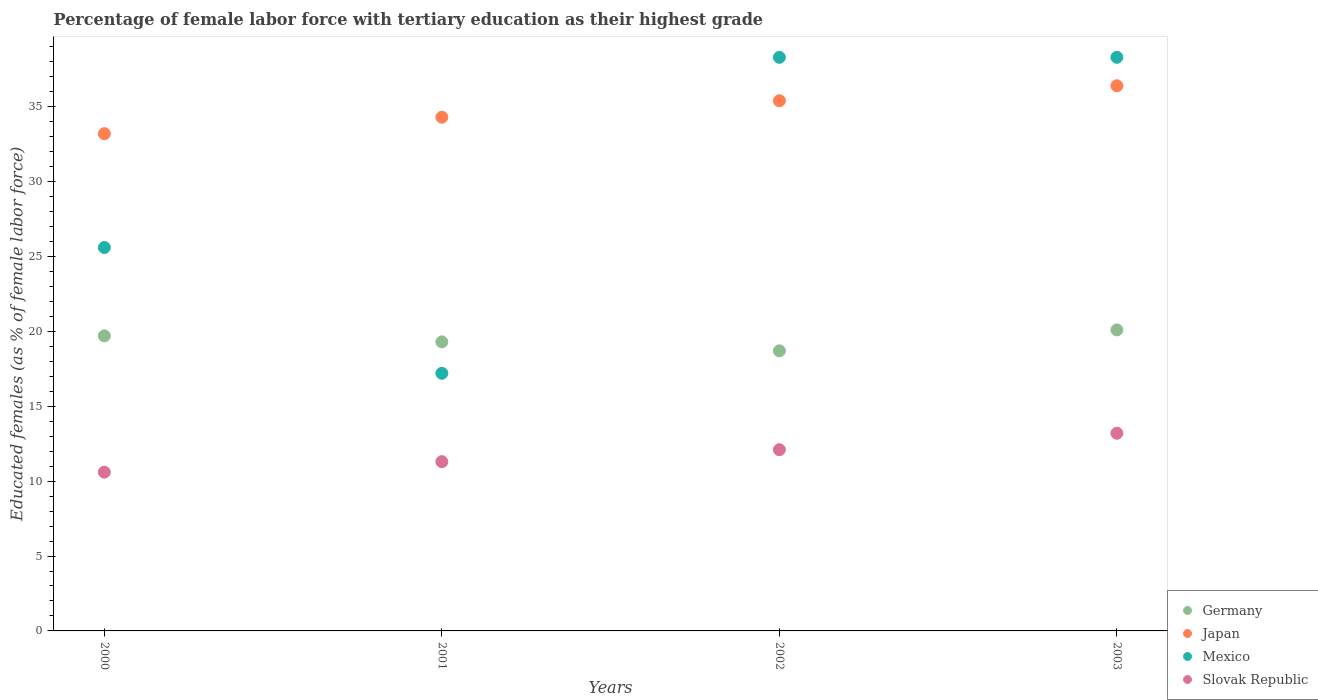Is the number of dotlines equal to the number of legend labels?
Your answer should be compact. Yes. What is the percentage of female labor force with tertiary education in Germany in 2003?
Offer a terse response. 20.1. Across all years, what is the maximum percentage of female labor force with tertiary education in Japan?
Keep it short and to the point. 36.4. Across all years, what is the minimum percentage of female labor force with tertiary education in Slovak Republic?
Your answer should be compact. 10.6. In which year was the percentage of female labor force with tertiary education in Slovak Republic maximum?
Offer a terse response. 2003. What is the total percentage of female labor force with tertiary education in Japan in the graph?
Ensure brevity in your answer.  139.3. What is the difference between the percentage of female labor force with tertiary education in Slovak Republic in 2001 and that in 2003?
Provide a succinct answer. -1.9. What is the difference between the percentage of female labor force with tertiary education in Mexico in 2003 and the percentage of female labor force with tertiary education in Japan in 2001?
Make the answer very short. 4. What is the average percentage of female labor force with tertiary education in Mexico per year?
Keep it short and to the point. 29.85. In the year 2001, what is the difference between the percentage of female labor force with tertiary education in Mexico and percentage of female labor force with tertiary education in Slovak Republic?
Offer a very short reply. 5.9. What is the ratio of the percentage of female labor force with tertiary education in Japan in 2000 to that in 2001?
Give a very brief answer. 0.97. What is the difference between the highest and the second highest percentage of female labor force with tertiary education in Slovak Republic?
Ensure brevity in your answer.  1.1. What is the difference between the highest and the lowest percentage of female labor force with tertiary education in Germany?
Offer a terse response. 1.4. In how many years, is the percentage of female labor force with tertiary education in Japan greater than the average percentage of female labor force with tertiary education in Japan taken over all years?
Your response must be concise. 2. Is it the case that in every year, the sum of the percentage of female labor force with tertiary education in Germany and percentage of female labor force with tertiary education in Mexico  is greater than the percentage of female labor force with tertiary education in Japan?
Your response must be concise. Yes. Does the percentage of female labor force with tertiary education in Mexico monotonically increase over the years?
Ensure brevity in your answer.  No. What is the difference between two consecutive major ticks on the Y-axis?
Offer a very short reply. 5. Does the graph contain grids?
Your answer should be compact. No. How many legend labels are there?
Offer a very short reply. 4. What is the title of the graph?
Provide a short and direct response. Percentage of female labor force with tertiary education as their highest grade. What is the label or title of the Y-axis?
Your answer should be compact. Educated females (as % of female labor force). What is the Educated females (as % of female labor force) in Germany in 2000?
Provide a short and direct response. 19.7. What is the Educated females (as % of female labor force) of Japan in 2000?
Ensure brevity in your answer.  33.2. What is the Educated females (as % of female labor force) in Mexico in 2000?
Keep it short and to the point. 25.6. What is the Educated females (as % of female labor force) in Slovak Republic in 2000?
Make the answer very short. 10.6. What is the Educated females (as % of female labor force) of Germany in 2001?
Offer a terse response. 19.3. What is the Educated females (as % of female labor force) in Japan in 2001?
Keep it short and to the point. 34.3. What is the Educated females (as % of female labor force) in Mexico in 2001?
Offer a very short reply. 17.2. What is the Educated females (as % of female labor force) of Slovak Republic in 2001?
Your response must be concise. 11.3. What is the Educated females (as % of female labor force) of Germany in 2002?
Offer a terse response. 18.7. What is the Educated females (as % of female labor force) of Japan in 2002?
Your answer should be very brief. 35.4. What is the Educated females (as % of female labor force) in Mexico in 2002?
Make the answer very short. 38.3. What is the Educated females (as % of female labor force) in Slovak Republic in 2002?
Your response must be concise. 12.1. What is the Educated females (as % of female labor force) in Germany in 2003?
Offer a very short reply. 20.1. What is the Educated females (as % of female labor force) in Japan in 2003?
Provide a succinct answer. 36.4. What is the Educated females (as % of female labor force) in Mexico in 2003?
Your answer should be very brief. 38.3. What is the Educated females (as % of female labor force) in Slovak Republic in 2003?
Keep it short and to the point. 13.2. Across all years, what is the maximum Educated females (as % of female labor force) of Germany?
Make the answer very short. 20.1. Across all years, what is the maximum Educated females (as % of female labor force) in Japan?
Provide a succinct answer. 36.4. Across all years, what is the maximum Educated females (as % of female labor force) in Mexico?
Your answer should be very brief. 38.3. Across all years, what is the maximum Educated females (as % of female labor force) of Slovak Republic?
Make the answer very short. 13.2. Across all years, what is the minimum Educated females (as % of female labor force) of Germany?
Give a very brief answer. 18.7. Across all years, what is the minimum Educated females (as % of female labor force) of Japan?
Keep it short and to the point. 33.2. Across all years, what is the minimum Educated females (as % of female labor force) of Mexico?
Provide a short and direct response. 17.2. Across all years, what is the minimum Educated females (as % of female labor force) of Slovak Republic?
Give a very brief answer. 10.6. What is the total Educated females (as % of female labor force) in Germany in the graph?
Make the answer very short. 77.8. What is the total Educated females (as % of female labor force) of Japan in the graph?
Your answer should be very brief. 139.3. What is the total Educated females (as % of female labor force) of Mexico in the graph?
Your answer should be very brief. 119.4. What is the total Educated females (as % of female labor force) in Slovak Republic in the graph?
Give a very brief answer. 47.2. What is the difference between the Educated females (as % of female labor force) in Germany in 2000 and that in 2001?
Give a very brief answer. 0.4. What is the difference between the Educated females (as % of female labor force) of Japan in 2000 and that in 2001?
Your response must be concise. -1.1. What is the difference between the Educated females (as % of female labor force) of Slovak Republic in 2000 and that in 2001?
Make the answer very short. -0.7. What is the difference between the Educated females (as % of female labor force) of Germany in 2000 and that in 2002?
Make the answer very short. 1. What is the difference between the Educated females (as % of female labor force) in Mexico in 2000 and that in 2003?
Offer a terse response. -12.7. What is the difference between the Educated females (as % of female labor force) in Japan in 2001 and that in 2002?
Your response must be concise. -1.1. What is the difference between the Educated females (as % of female labor force) of Mexico in 2001 and that in 2002?
Your response must be concise. -21.1. What is the difference between the Educated females (as % of female labor force) in Germany in 2001 and that in 2003?
Provide a short and direct response. -0.8. What is the difference between the Educated females (as % of female labor force) in Japan in 2001 and that in 2003?
Offer a terse response. -2.1. What is the difference between the Educated females (as % of female labor force) of Mexico in 2001 and that in 2003?
Your response must be concise. -21.1. What is the difference between the Educated females (as % of female labor force) of Slovak Republic in 2001 and that in 2003?
Give a very brief answer. -1.9. What is the difference between the Educated females (as % of female labor force) of Germany in 2002 and that in 2003?
Your answer should be compact. -1.4. What is the difference between the Educated females (as % of female labor force) of Germany in 2000 and the Educated females (as % of female labor force) of Japan in 2001?
Your answer should be compact. -14.6. What is the difference between the Educated females (as % of female labor force) of Japan in 2000 and the Educated females (as % of female labor force) of Mexico in 2001?
Ensure brevity in your answer.  16. What is the difference between the Educated females (as % of female labor force) of Japan in 2000 and the Educated females (as % of female labor force) of Slovak Republic in 2001?
Make the answer very short. 21.9. What is the difference between the Educated females (as % of female labor force) of Germany in 2000 and the Educated females (as % of female labor force) of Japan in 2002?
Offer a terse response. -15.7. What is the difference between the Educated females (as % of female labor force) in Germany in 2000 and the Educated females (as % of female labor force) in Mexico in 2002?
Provide a succinct answer. -18.6. What is the difference between the Educated females (as % of female labor force) in Germany in 2000 and the Educated females (as % of female labor force) in Slovak Republic in 2002?
Offer a terse response. 7.6. What is the difference between the Educated females (as % of female labor force) of Japan in 2000 and the Educated females (as % of female labor force) of Mexico in 2002?
Your answer should be very brief. -5.1. What is the difference between the Educated females (as % of female labor force) of Japan in 2000 and the Educated females (as % of female labor force) of Slovak Republic in 2002?
Your answer should be compact. 21.1. What is the difference between the Educated females (as % of female labor force) in Mexico in 2000 and the Educated females (as % of female labor force) in Slovak Republic in 2002?
Give a very brief answer. 13.5. What is the difference between the Educated females (as % of female labor force) of Germany in 2000 and the Educated females (as % of female labor force) of Japan in 2003?
Provide a succinct answer. -16.7. What is the difference between the Educated females (as % of female labor force) in Germany in 2000 and the Educated females (as % of female labor force) in Mexico in 2003?
Offer a very short reply. -18.6. What is the difference between the Educated females (as % of female labor force) in Japan in 2000 and the Educated females (as % of female labor force) in Mexico in 2003?
Offer a terse response. -5.1. What is the difference between the Educated females (as % of female labor force) in Mexico in 2000 and the Educated females (as % of female labor force) in Slovak Republic in 2003?
Your answer should be compact. 12.4. What is the difference between the Educated females (as % of female labor force) in Germany in 2001 and the Educated females (as % of female labor force) in Japan in 2002?
Provide a short and direct response. -16.1. What is the difference between the Educated females (as % of female labor force) in Germany in 2001 and the Educated females (as % of female labor force) in Mexico in 2002?
Provide a succinct answer. -19. What is the difference between the Educated females (as % of female labor force) of Germany in 2001 and the Educated females (as % of female labor force) of Slovak Republic in 2002?
Make the answer very short. 7.2. What is the difference between the Educated females (as % of female labor force) of Japan in 2001 and the Educated females (as % of female labor force) of Slovak Republic in 2002?
Provide a succinct answer. 22.2. What is the difference between the Educated females (as % of female labor force) of Germany in 2001 and the Educated females (as % of female labor force) of Japan in 2003?
Your answer should be very brief. -17.1. What is the difference between the Educated females (as % of female labor force) of Germany in 2001 and the Educated females (as % of female labor force) of Mexico in 2003?
Your answer should be compact. -19. What is the difference between the Educated females (as % of female labor force) in Germany in 2001 and the Educated females (as % of female labor force) in Slovak Republic in 2003?
Provide a short and direct response. 6.1. What is the difference between the Educated females (as % of female labor force) in Japan in 2001 and the Educated females (as % of female labor force) in Slovak Republic in 2003?
Your response must be concise. 21.1. What is the difference between the Educated females (as % of female labor force) of Mexico in 2001 and the Educated females (as % of female labor force) of Slovak Republic in 2003?
Offer a terse response. 4. What is the difference between the Educated females (as % of female labor force) of Germany in 2002 and the Educated females (as % of female labor force) of Japan in 2003?
Give a very brief answer. -17.7. What is the difference between the Educated females (as % of female labor force) of Germany in 2002 and the Educated females (as % of female labor force) of Mexico in 2003?
Offer a terse response. -19.6. What is the difference between the Educated females (as % of female labor force) of Japan in 2002 and the Educated females (as % of female labor force) of Mexico in 2003?
Ensure brevity in your answer.  -2.9. What is the difference between the Educated females (as % of female labor force) of Mexico in 2002 and the Educated females (as % of female labor force) of Slovak Republic in 2003?
Your response must be concise. 25.1. What is the average Educated females (as % of female labor force) of Germany per year?
Make the answer very short. 19.45. What is the average Educated females (as % of female labor force) in Japan per year?
Ensure brevity in your answer.  34.83. What is the average Educated females (as % of female labor force) in Mexico per year?
Your response must be concise. 29.85. In the year 2000, what is the difference between the Educated females (as % of female labor force) of Germany and Educated females (as % of female labor force) of Slovak Republic?
Offer a terse response. 9.1. In the year 2000, what is the difference between the Educated females (as % of female labor force) in Japan and Educated females (as % of female labor force) in Slovak Republic?
Provide a succinct answer. 22.6. In the year 2000, what is the difference between the Educated females (as % of female labor force) in Mexico and Educated females (as % of female labor force) in Slovak Republic?
Your response must be concise. 15. In the year 2001, what is the difference between the Educated females (as % of female labor force) in Germany and Educated females (as % of female labor force) in Mexico?
Provide a succinct answer. 2.1. In the year 2001, what is the difference between the Educated females (as % of female labor force) in Japan and Educated females (as % of female labor force) in Slovak Republic?
Provide a succinct answer. 23. In the year 2002, what is the difference between the Educated females (as % of female labor force) in Germany and Educated females (as % of female labor force) in Japan?
Provide a short and direct response. -16.7. In the year 2002, what is the difference between the Educated females (as % of female labor force) of Germany and Educated females (as % of female labor force) of Mexico?
Give a very brief answer. -19.6. In the year 2002, what is the difference between the Educated females (as % of female labor force) of Germany and Educated females (as % of female labor force) of Slovak Republic?
Your response must be concise. 6.6. In the year 2002, what is the difference between the Educated females (as % of female labor force) in Japan and Educated females (as % of female labor force) in Mexico?
Ensure brevity in your answer.  -2.9. In the year 2002, what is the difference between the Educated females (as % of female labor force) of Japan and Educated females (as % of female labor force) of Slovak Republic?
Offer a terse response. 23.3. In the year 2002, what is the difference between the Educated females (as % of female labor force) in Mexico and Educated females (as % of female labor force) in Slovak Republic?
Make the answer very short. 26.2. In the year 2003, what is the difference between the Educated females (as % of female labor force) of Germany and Educated females (as % of female labor force) of Japan?
Provide a short and direct response. -16.3. In the year 2003, what is the difference between the Educated females (as % of female labor force) in Germany and Educated females (as % of female labor force) in Mexico?
Provide a succinct answer. -18.2. In the year 2003, what is the difference between the Educated females (as % of female labor force) of Germany and Educated females (as % of female labor force) of Slovak Republic?
Offer a terse response. 6.9. In the year 2003, what is the difference between the Educated females (as % of female labor force) of Japan and Educated females (as % of female labor force) of Slovak Republic?
Provide a short and direct response. 23.2. In the year 2003, what is the difference between the Educated females (as % of female labor force) of Mexico and Educated females (as % of female labor force) of Slovak Republic?
Your answer should be very brief. 25.1. What is the ratio of the Educated females (as % of female labor force) in Germany in 2000 to that in 2001?
Your answer should be compact. 1.02. What is the ratio of the Educated females (as % of female labor force) in Japan in 2000 to that in 2001?
Make the answer very short. 0.97. What is the ratio of the Educated females (as % of female labor force) of Mexico in 2000 to that in 2001?
Provide a short and direct response. 1.49. What is the ratio of the Educated females (as % of female labor force) in Slovak Republic in 2000 to that in 2001?
Give a very brief answer. 0.94. What is the ratio of the Educated females (as % of female labor force) of Germany in 2000 to that in 2002?
Your answer should be compact. 1.05. What is the ratio of the Educated females (as % of female labor force) of Japan in 2000 to that in 2002?
Make the answer very short. 0.94. What is the ratio of the Educated females (as % of female labor force) of Mexico in 2000 to that in 2002?
Your answer should be very brief. 0.67. What is the ratio of the Educated females (as % of female labor force) in Slovak Republic in 2000 to that in 2002?
Make the answer very short. 0.88. What is the ratio of the Educated females (as % of female labor force) in Germany in 2000 to that in 2003?
Make the answer very short. 0.98. What is the ratio of the Educated females (as % of female labor force) of Japan in 2000 to that in 2003?
Give a very brief answer. 0.91. What is the ratio of the Educated females (as % of female labor force) in Mexico in 2000 to that in 2003?
Offer a terse response. 0.67. What is the ratio of the Educated females (as % of female labor force) of Slovak Republic in 2000 to that in 2003?
Your response must be concise. 0.8. What is the ratio of the Educated females (as % of female labor force) in Germany in 2001 to that in 2002?
Your answer should be compact. 1.03. What is the ratio of the Educated females (as % of female labor force) in Japan in 2001 to that in 2002?
Provide a short and direct response. 0.97. What is the ratio of the Educated females (as % of female labor force) of Mexico in 2001 to that in 2002?
Your answer should be compact. 0.45. What is the ratio of the Educated females (as % of female labor force) in Slovak Republic in 2001 to that in 2002?
Provide a succinct answer. 0.93. What is the ratio of the Educated females (as % of female labor force) of Germany in 2001 to that in 2003?
Your answer should be compact. 0.96. What is the ratio of the Educated females (as % of female labor force) in Japan in 2001 to that in 2003?
Your answer should be very brief. 0.94. What is the ratio of the Educated females (as % of female labor force) in Mexico in 2001 to that in 2003?
Make the answer very short. 0.45. What is the ratio of the Educated females (as % of female labor force) of Slovak Republic in 2001 to that in 2003?
Give a very brief answer. 0.86. What is the ratio of the Educated females (as % of female labor force) of Germany in 2002 to that in 2003?
Your answer should be very brief. 0.93. What is the ratio of the Educated females (as % of female labor force) in Japan in 2002 to that in 2003?
Offer a terse response. 0.97. What is the difference between the highest and the second highest Educated females (as % of female labor force) in Germany?
Ensure brevity in your answer.  0.4. What is the difference between the highest and the second highest Educated females (as % of female labor force) in Japan?
Offer a terse response. 1. What is the difference between the highest and the second highest Educated females (as % of female labor force) of Mexico?
Provide a short and direct response. 0. What is the difference between the highest and the second highest Educated females (as % of female labor force) of Slovak Republic?
Provide a short and direct response. 1.1. What is the difference between the highest and the lowest Educated females (as % of female labor force) in Mexico?
Keep it short and to the point. 21.1. What is the difference between the highest and the lowest Educated females (as % of female labor force) in Slovak Republic?
Offer a terse response. 2.6. 